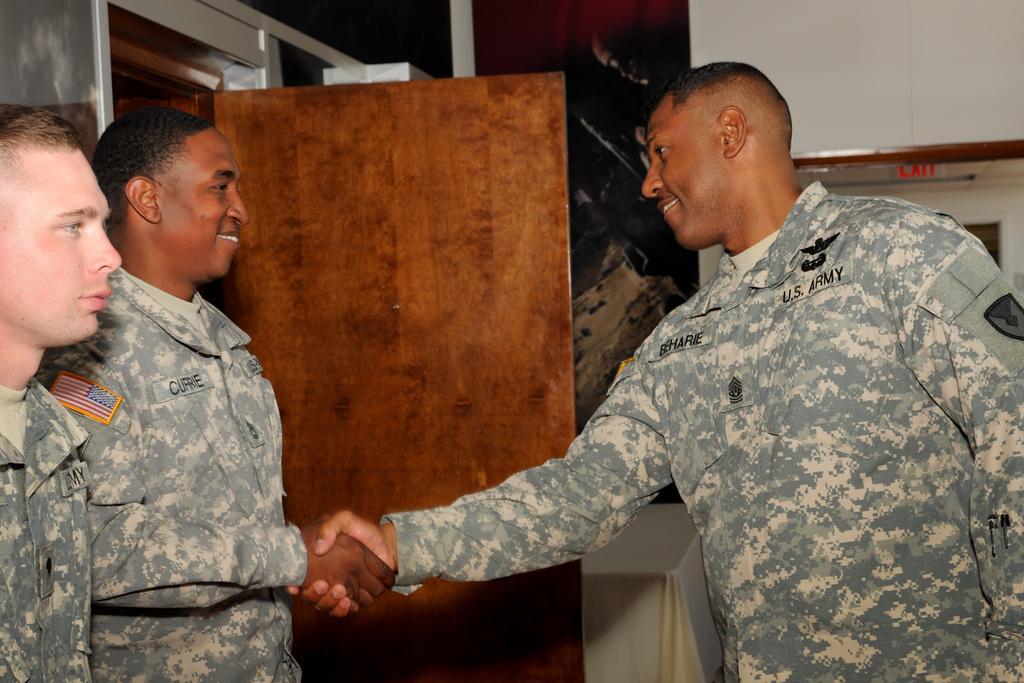In one or two sentences, can you explain what this image depicts? In this picture couple of men shaking their hands with smile on their faces and I can see another man on the left side of the picture and I can see a wooden plank and I can see a table and there is a cloth on it. 